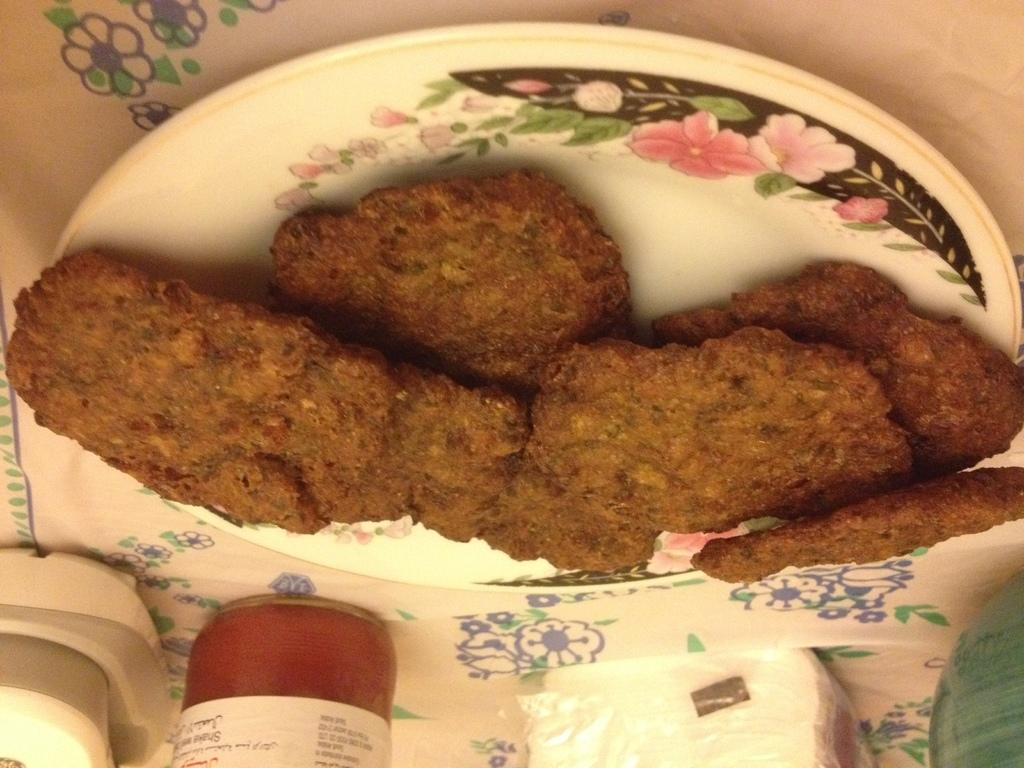What is the main subject of the image? There is a food item on a plate in the image. Can you describe the background of the image? There are items visible in the background of the image. What type of object can be seen in the background? There is an object in the background of the image. Is there any poison visible in the image? There is no mention of poison in the image, and it is not visible in the provided facts. 